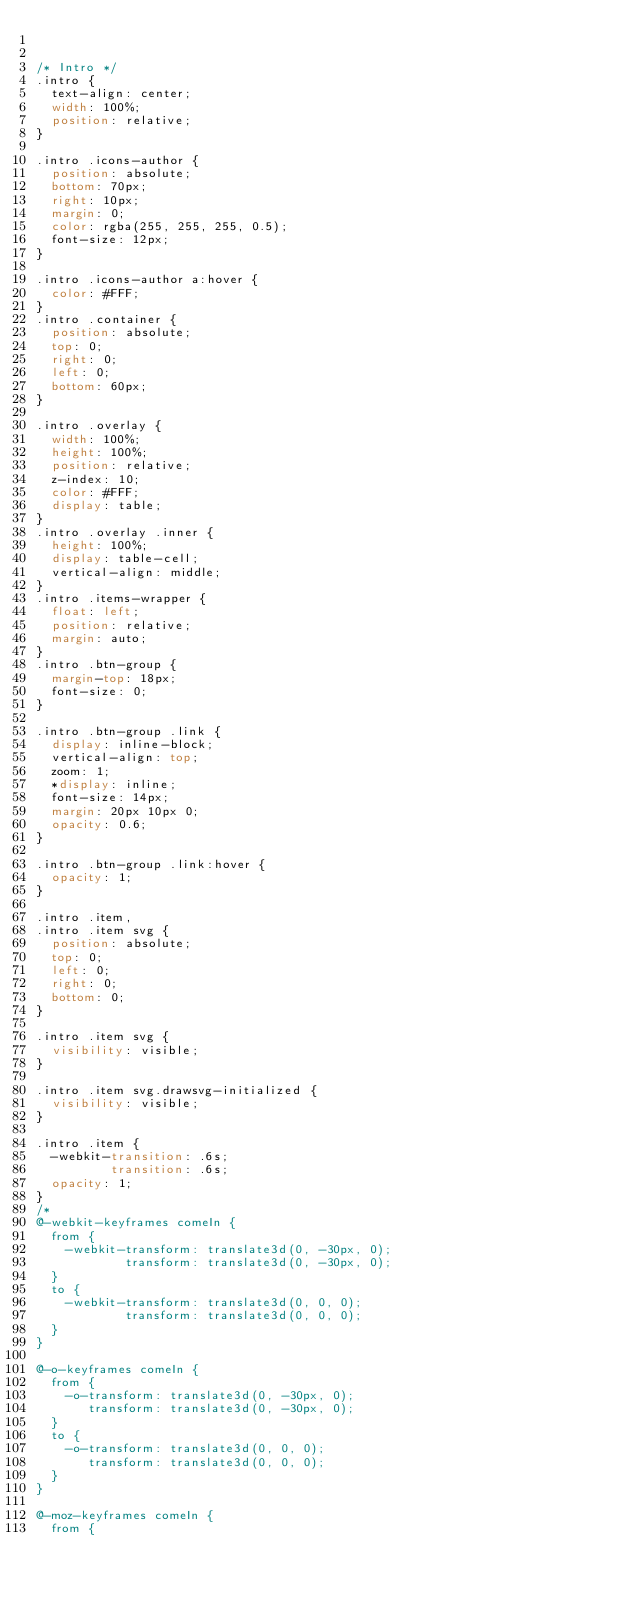Convert code to text. <code><loc_0><loc_0><loc_500><loc_500><_CSS_>

/* Intro */
.intro {
  text-align: center;
  width: 100%;
  position: relative;
}

.intro .icons-author {
  position: absolute;
  bottom: 70px;
  right: 10px;
  margin: 0;
  color: rgba(255, 255, 255, 0.5);
  font-size: 12px;
}

.intro .icons-author a:hover {
  color: #FFF;
}
.intro .container {
  position: absolute;
  top: 0;
  right: 0;
  left: 0;
  bottom: 60px;
}

.intro .overlay {
  width: 100%;
  height: 100%;
  position: relative;
  z-index: 10;
  color: #FFF;
  display: table;
}
.intro .overlay .inner {
  height: 100%;
  display: table-cell;
  vertical-align: middle;
}
.intro .items-wrapper {
  float: left;
  position: relative;
  margin: auto;
}
.intro .btn-group {
  margin-top: 18px;
  font-size: 0;
}

.intro .btn-group .link {
  display: inline-block;
  vertical-align: top;
  zoom: 1;
  *display: inline;
  font-size: 14px;
  margin: 20px 10px 0;
  opacity: 0.6;
}

.intro .btn-group .link:hover {
  opacity: 1;
}

.intro .item,
.intro .item svg {
  position: absolute;
  top: 0;
  left: 0;
  right: 0;
  bottom: 0;
}

.intro .item svg {
  visibility: visible;
}

.intro .item svg.drawsvg-initialized {
  visibility: visible;
}

.intro .item {
  -webkit-transition: .6s;
          transition: .6s;
  opacity: 1;
}
/*
@-webkit-keyframes comeIn {
  from {
    -webkit-transform: translate3d(0, -30px, 0);
            transform: translate3d(0, -30px, 0);
  }
  to {
    -webkit-transform: translate3d(0, 0, 0);
            transform: translate3d(0, 0, 0);
  }
}

@-o-keyframes comeIn {
  from {
    -o-transform: translate3d(0, -30px, 0);
       transform: translate3d(0, -30px, 0);
  }
  to {
    -o-transform: translate3d(0, 0, 0);
       transform: translate3d(0, 0, 0);
  }
}

@-moz-keyframes comeIn {
  from {</code> 